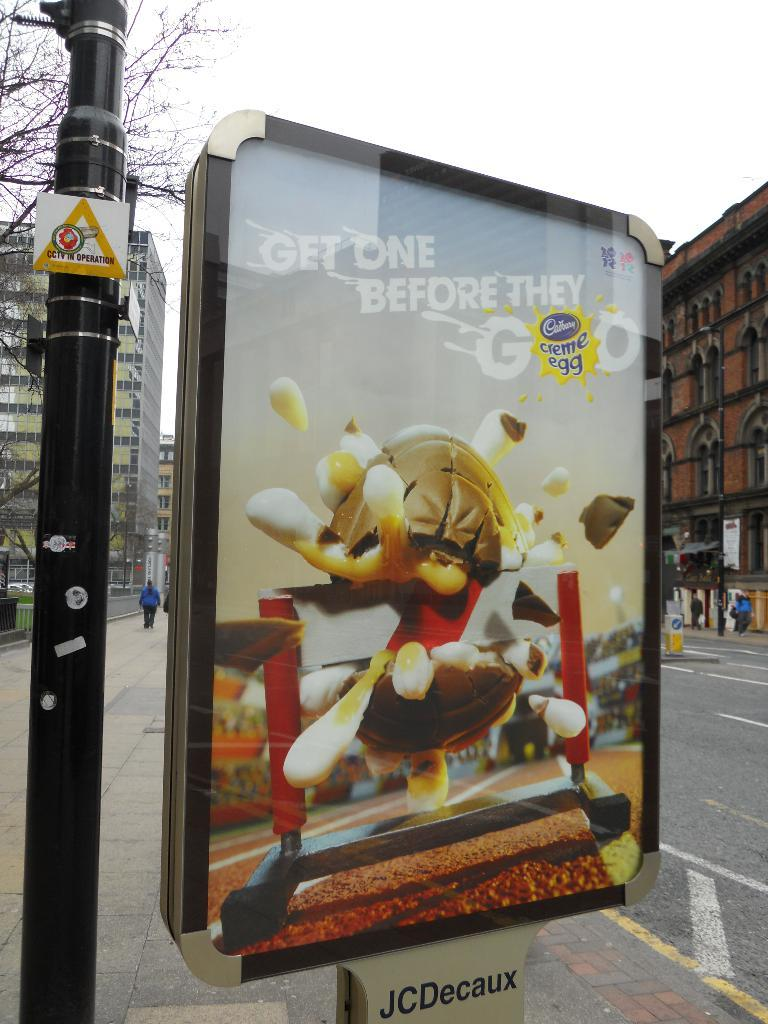<image>
Provide a brief description of the given image. An advertisement for Cadbury Creme Eggs proclaims "Get One Before They Go". 